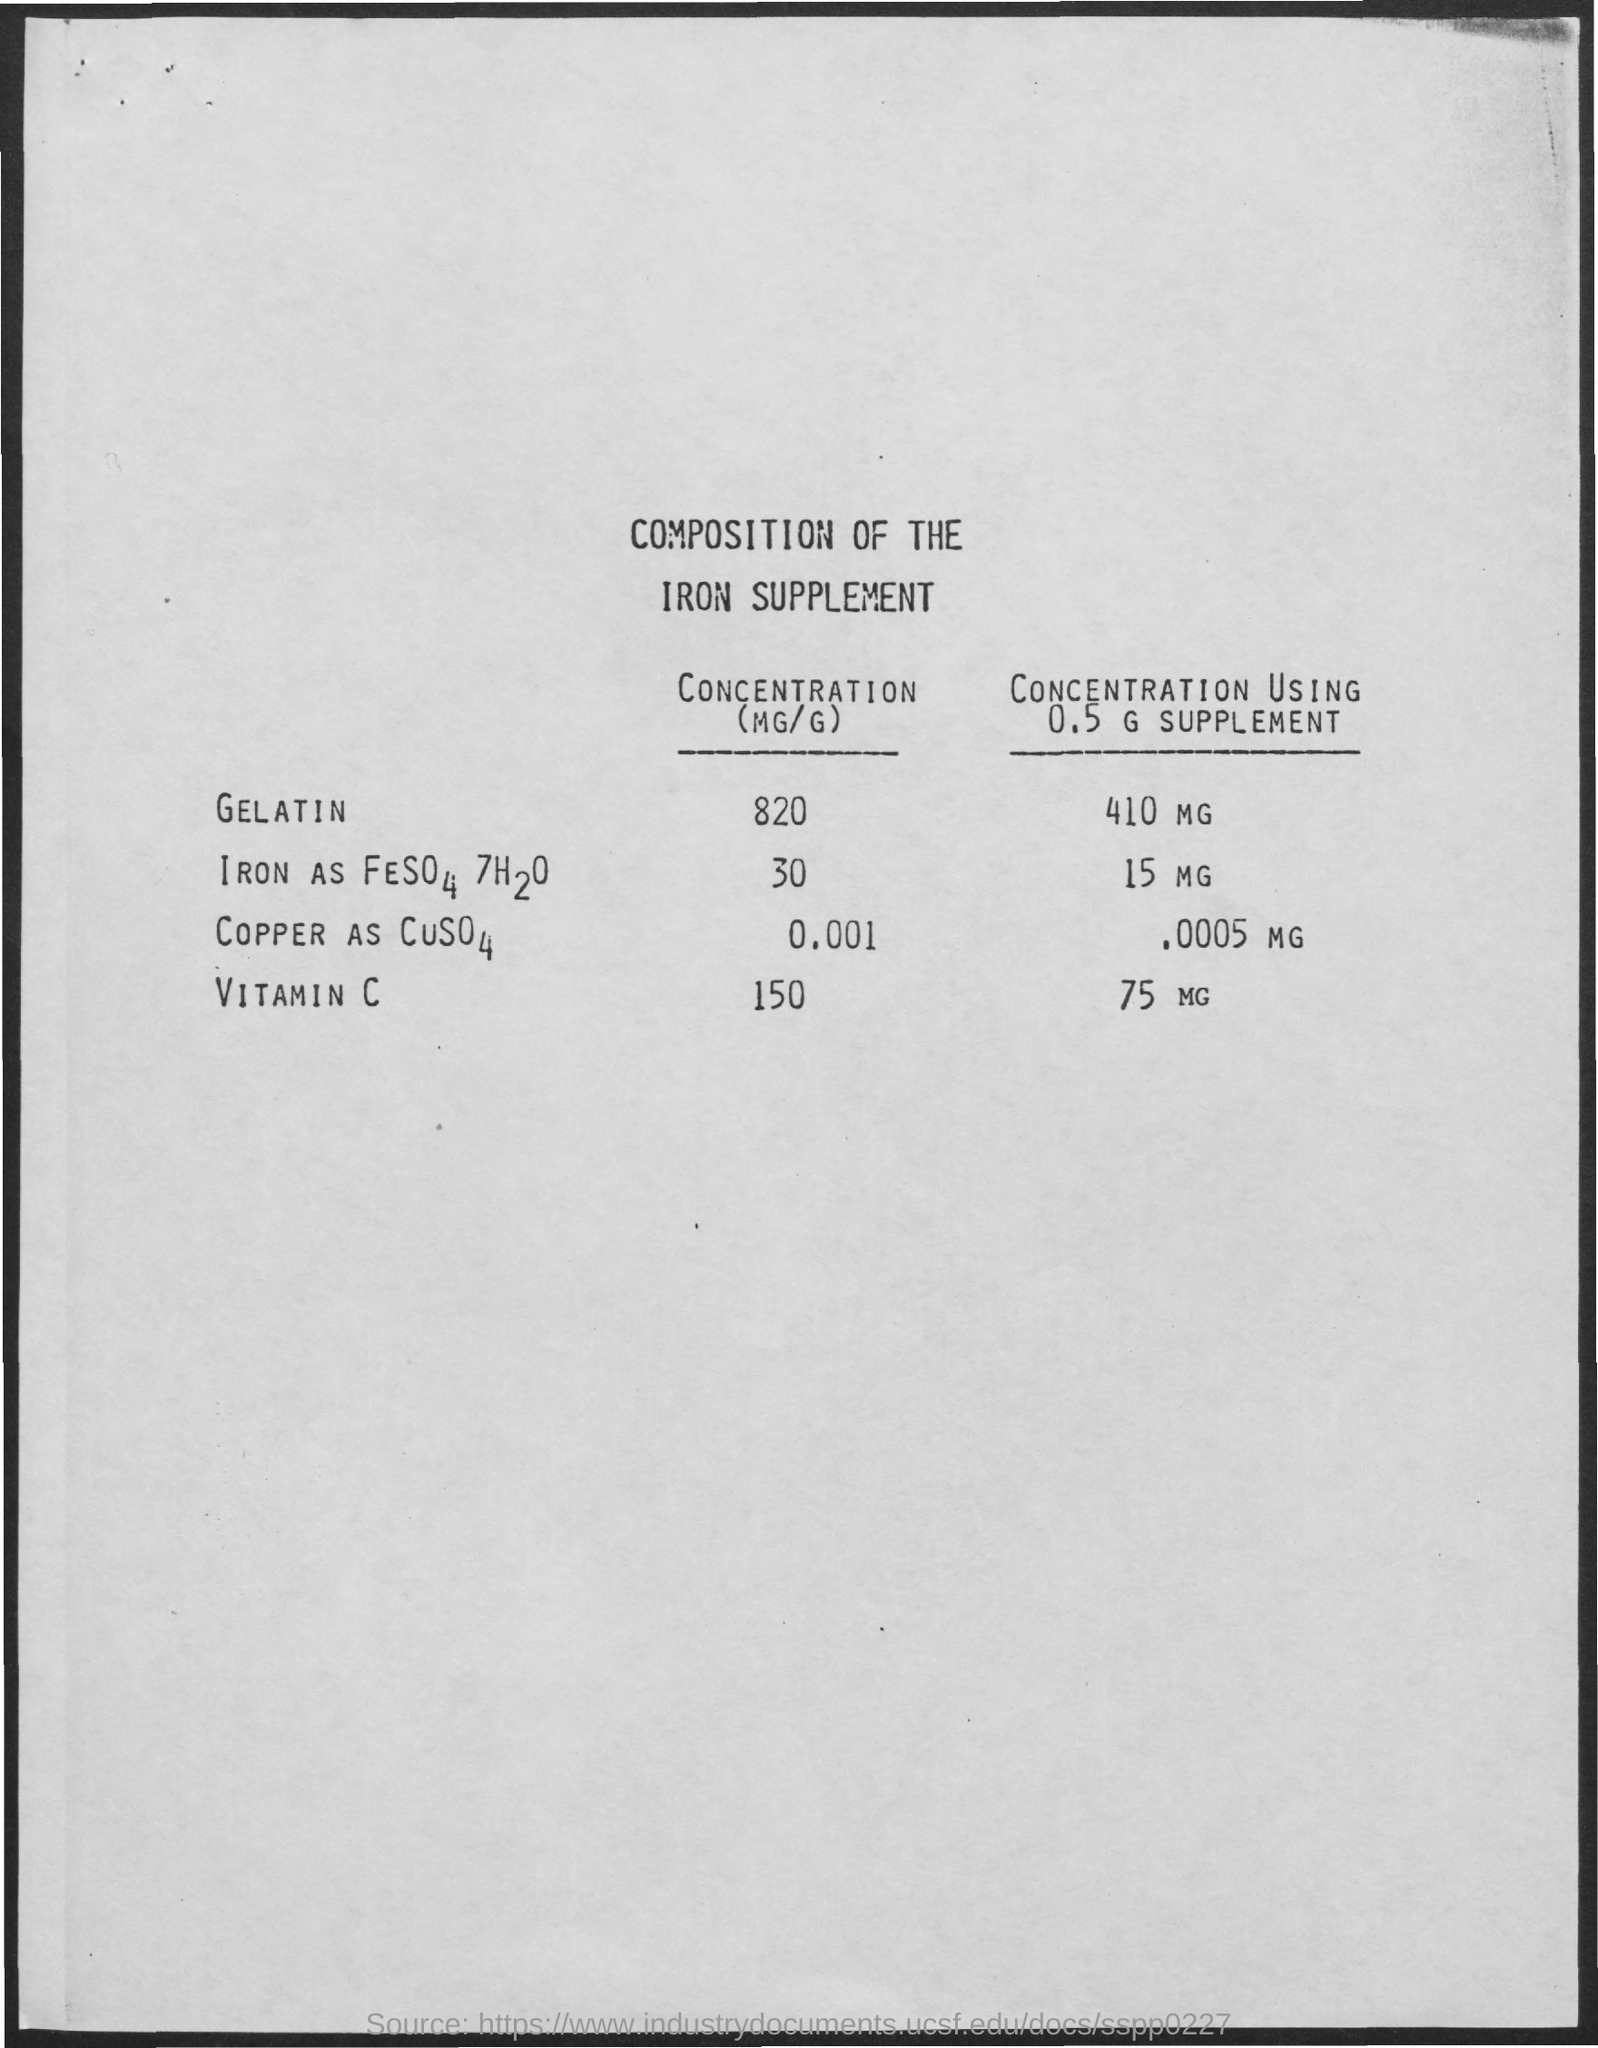What is the concentration value of gelatin ?
Your answer should be very brief. 820. What is the concentration using 0.5 g supplement value for gelatin ?
Give a very brief answer. 410 mg. What is the concentration value of vitamin c ?
Provide a short and direct response. 150. 